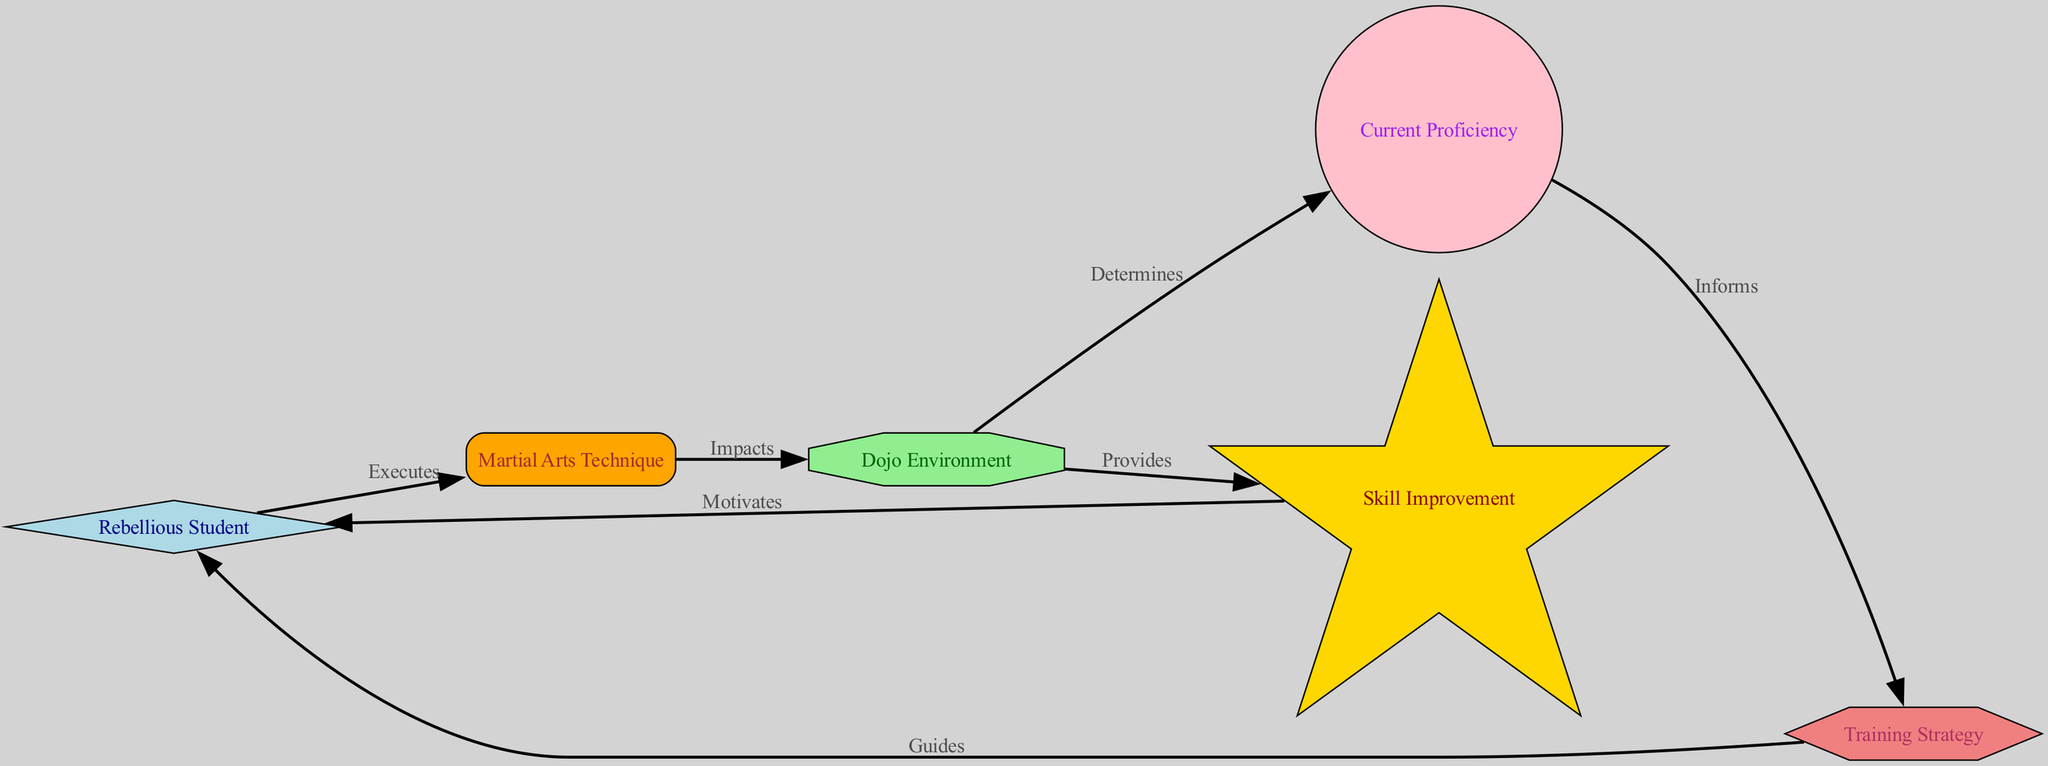What is the shape of the "Rebellious Student" node? The "Rebellious Student" node is represented as a diamond shape, which is specified in the node styles where it's defined.
Answer: diamond How many nodes are present in the diagram? The diagram contains six nodes, which include the Rebellious Student, Dojo Environment, Martial Arts Technique, Skill Improvement, Current Proficiency, and Training Strategy.
Answer: six What does the "Martial Arts Technique" node do to the "Dojo Environment"? The "Martial Arts Technique" node impacts the "Dojo Environment," as indicated by the directed edge between them labeled "Impacts."
Answer: impacts Which node motivates the "Rebellious Student"? The "Skill Improvement" node motivates the "Rebellious Student," as per the directed edge labeled "Motivates" pointing back from "Skill Improvement" to "Rebellious Student."
Answer: Skill Improvement What type of node is the "Training Strategy"? The "Training Strategy" node is represented as a hexagon shape in the diagram, which is specified in the custom node styles used to define its appearance.
Answer: hexagon How does the "Current Proficiency" node affect the "Training Strategy" node? The "Current Proficiency" node informs the "Training Strategy" node, as indicated by the directed edge labeled "Informs" pointing from "Current Proficiency" to "Training Strategy." This shows that the student's proficiency directly influences the strategy used for training.
Answer: informs What does the "Dojo Environment" node provide? The "Dojo Environment" node provides the "Skill Improvement" node, as indicated by the directed edge labeled "Provides," thus establishing that the environment grants feedback on skill enhancement.
Answer: Skill Improvement Which node is affected by the "Martial Arts Technique"? The "Dojo Environment" node is affected by the "Martial Arts Technique" node, since it is indicated by the directed edge labeled "Impacts" from "Martial Arts Technique" to "Dojo Environment."
Answer: Dojo Environment 